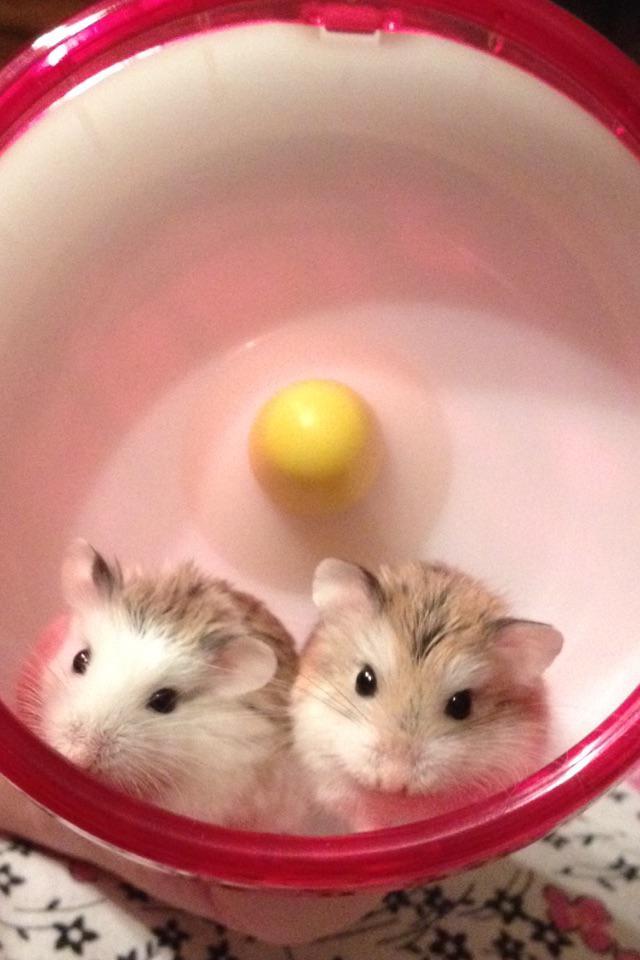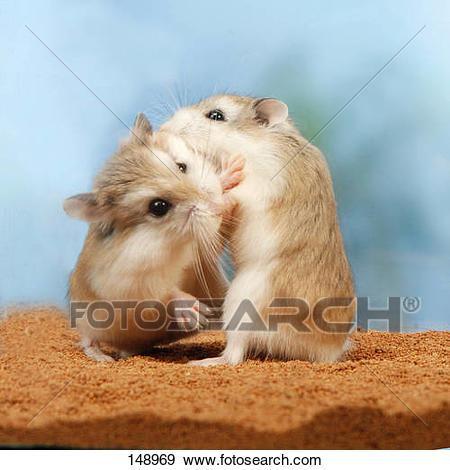The first image is the image on the left, the second image is the image on the right. Analyze the images presented: Is the assertion "Cupped hands hold at least one pet rodent in one image." valid? Answer yes or no. No. The first image is the image on the left, the second image is the image on the right. Examine the images to the left and right. Is the description "There are two pairs of hamsters" accurate? Answer yes or no. Yes. 